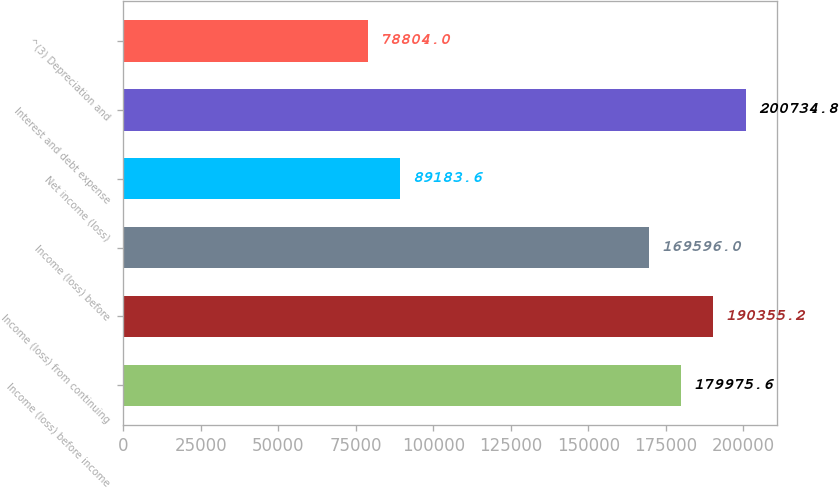Convert chart to OTSL. <chart><loc_0><loc_0><loc_500><loc_500><bar_chart><fcel>Income (loss) before income<fcel>Income (loss) from continuing<fcel>Income (loss) before<fcel>Net income (loss)<fcel>Interest and debt expense<fcel>^(3) Depreciation and<nl><fcel>179976<fcel>190355<fcel>169596<fcel>89183.6<fcel>200735<fcel>78804<nl></chart> 